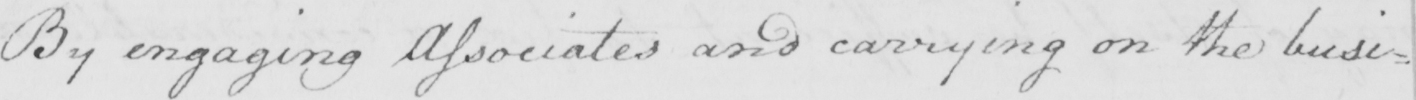Please transcribe the handwritten text in this image. By engaging Associates and carrying on the busi= 